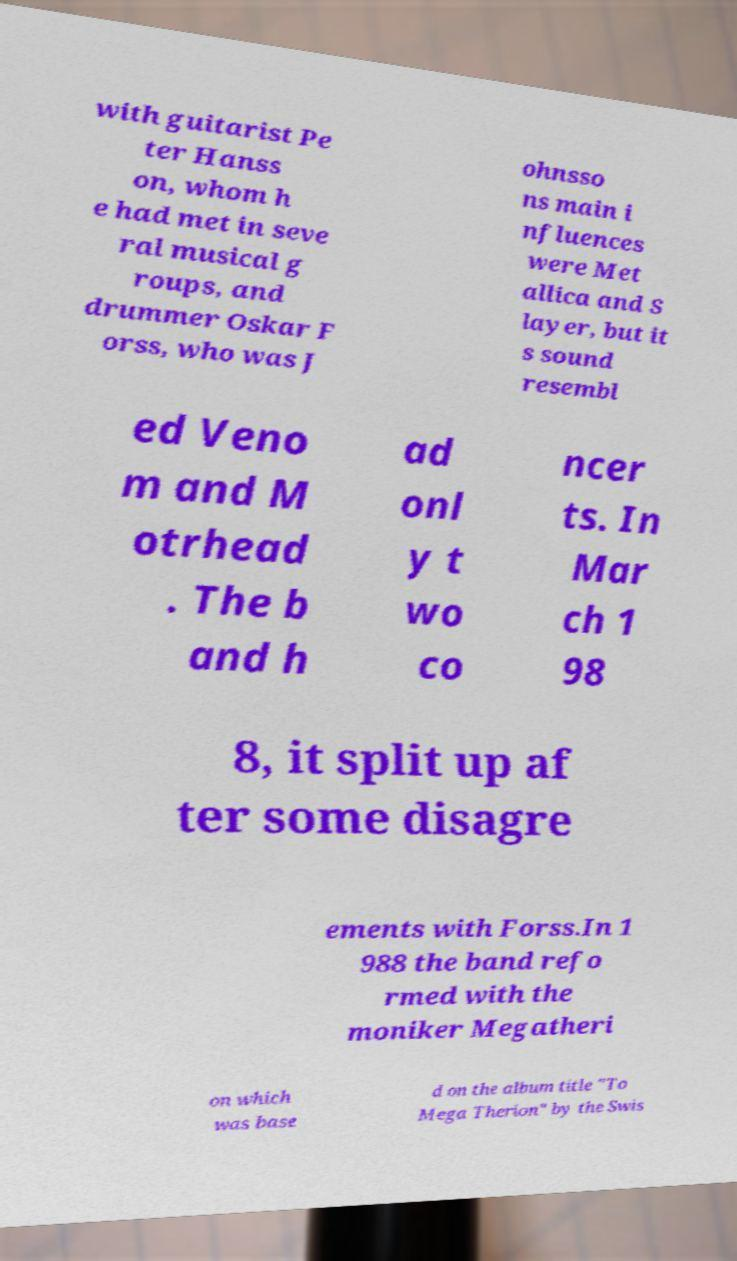There's text embedded in this image that I need extracted. Can you transcribe it verbatim? with guitarist Pe ter Hanss on, whom h e had met in seve ral musical g roups, and drummer Oskar F orss, who was J ohnsso ns main i nfluences were Met allica and S layer, but it s sound resembl ed Veno m and M otrhead . The b and h ad onl y t wo co ncer ts. In Mar ch 1 98 8, it split up af ter some disagre ements with Forss.In 1 988 the band refo rmed with the moniker Megatheri on which was base d on the album title "To Mega Therion" by the Swis 